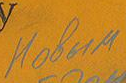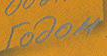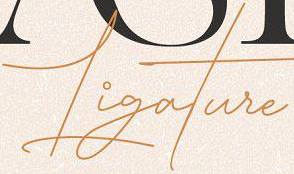Identify the words shown in these images in order, separated by a semicolon. Hobum; rodom; Ligature 